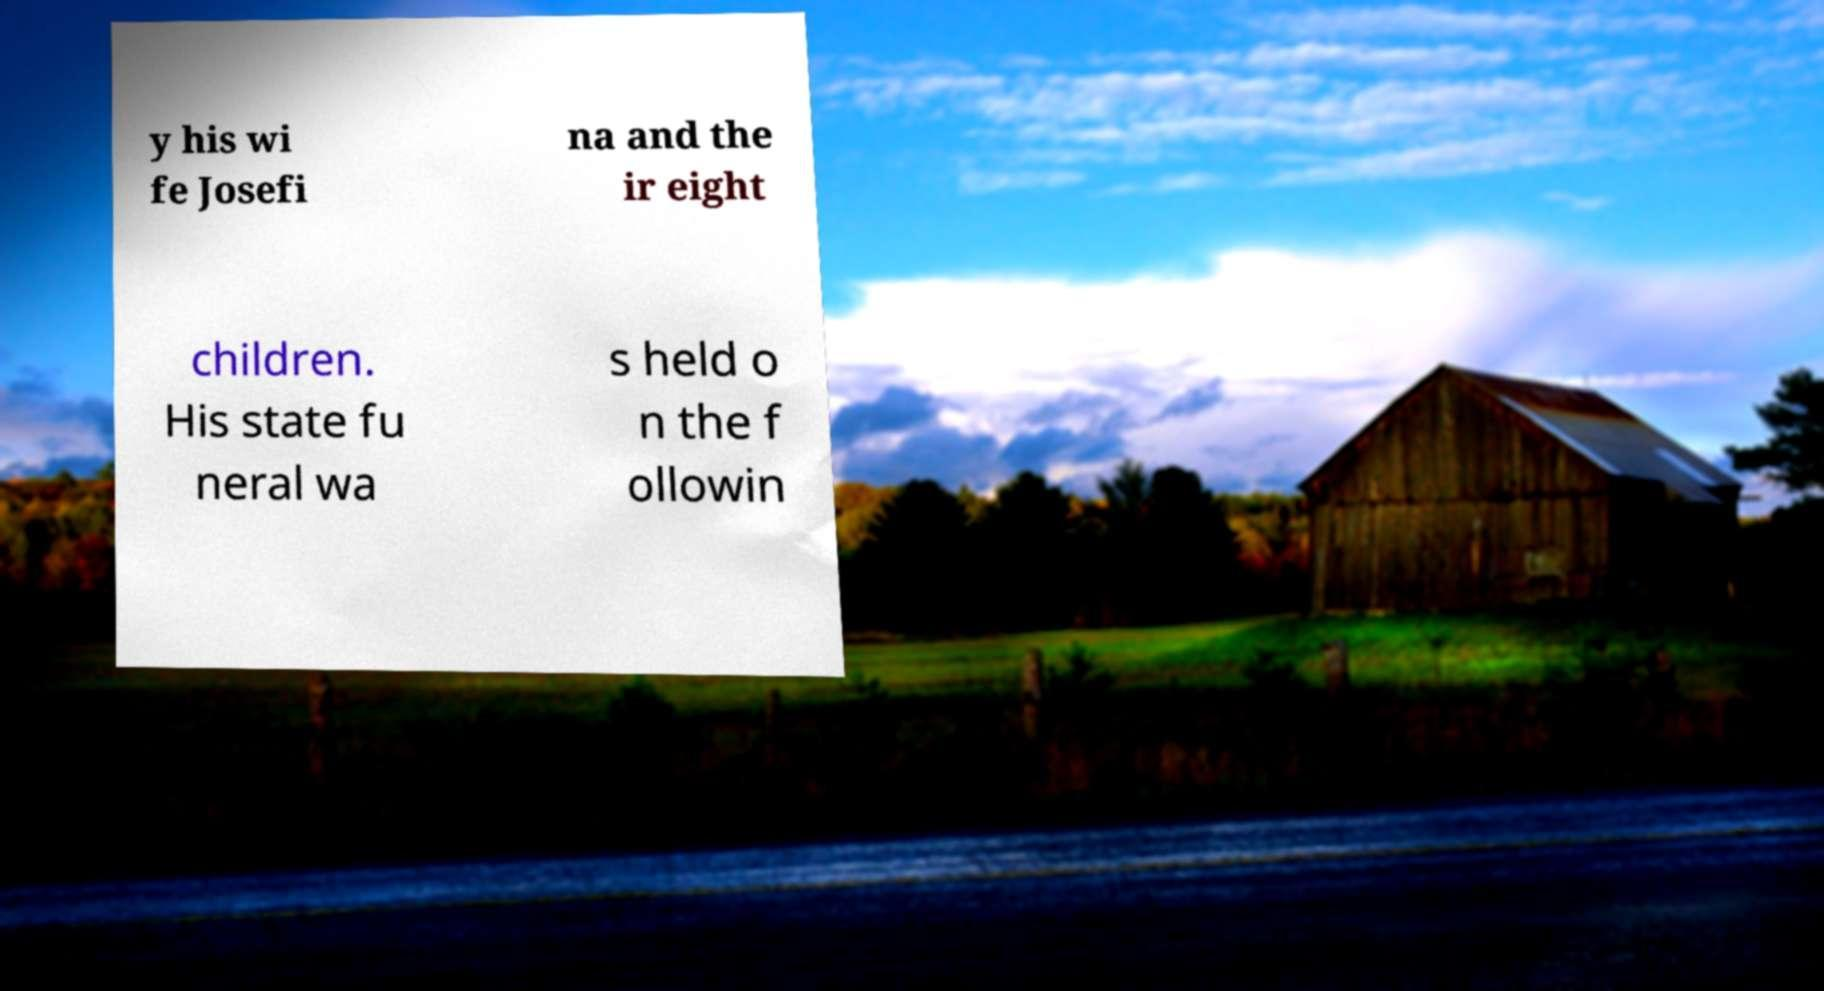What messages or text are displayed in this image? I need them in a readable, typed format. y his wi fe Josefi na and the ir eight children. His state fu neral wa s held o n the f ollowin 